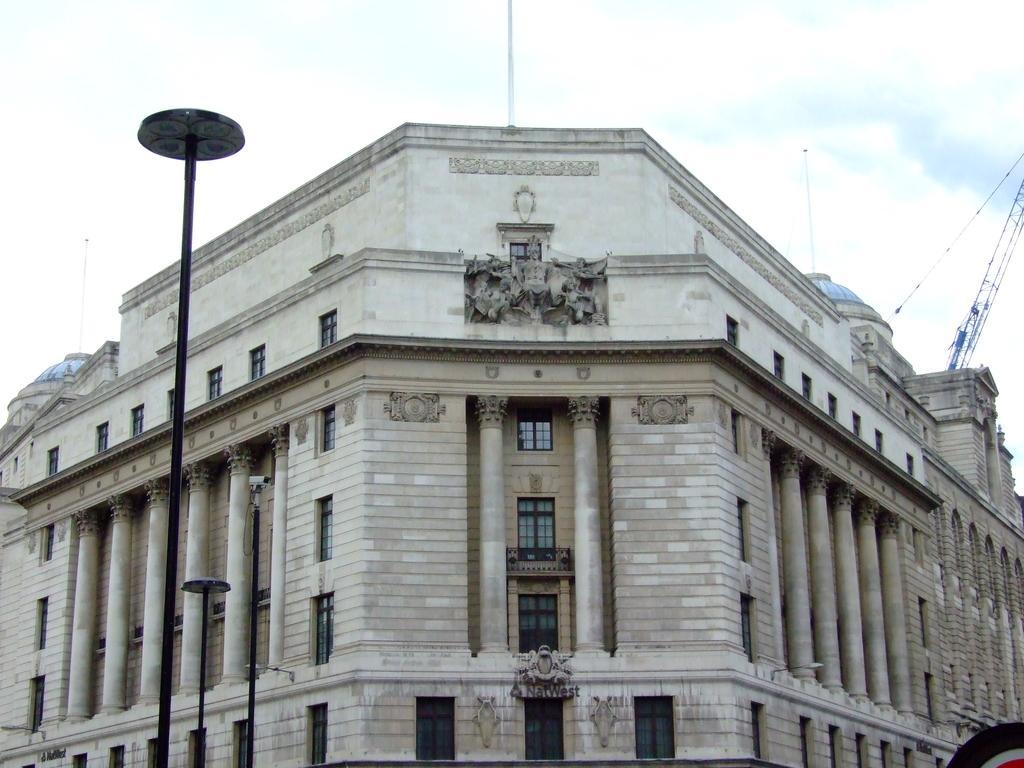Please provide a concise description of this image. In this picture we can see a building with windows and pillars. In front of the building, there are poles. On the right side of the image, it looks like a crane. At the top of the image, there is the sky. 